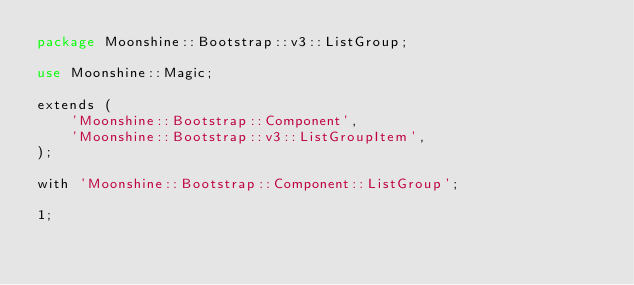Convert code to text. <code><loc_0><loc_0><loc_500><loc_500><_Perl_>package Moonshine::Bootstrap::v3::ListGroup;

use Moonshine::Magic;

extends (
    'Moonshine::Bootstrap::Component',
    'Moonshine::Bootstrap::v3::ListGroupItem',
); 

with 'Moonshine::Bootstrap::Component::ListGroup';

1;


</code> 